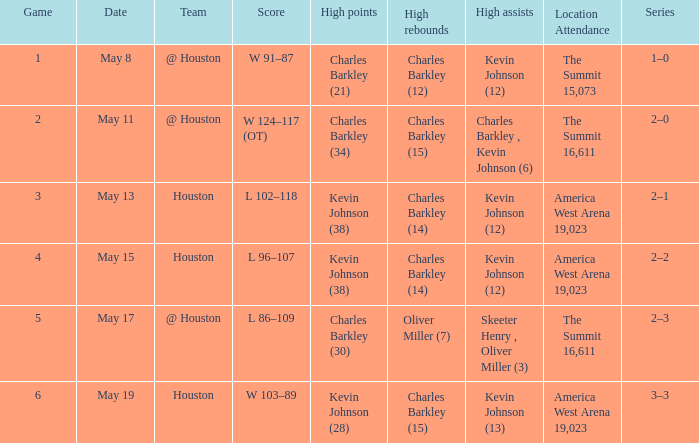How many different high points results are there for the game on May 15? 1.0. 